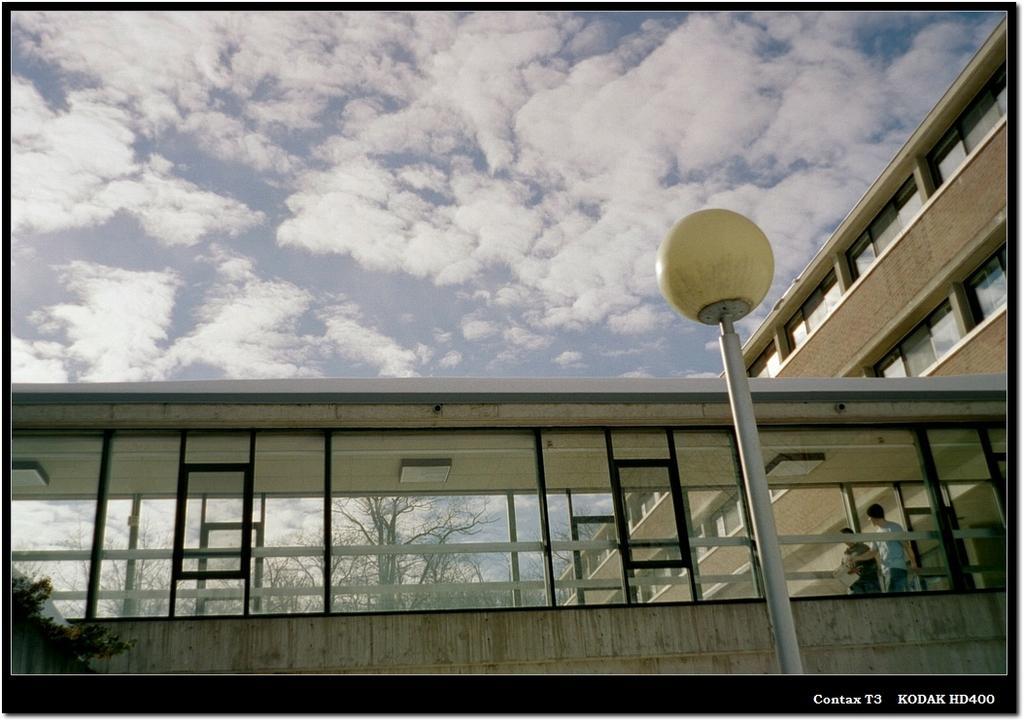Describe this image in one or two sentences. In this image there is a bridge in the middle. On the right side there is a pole on which there is a bulb. At the top there is the sky. On the right side there is a building with the glass windows. The bridge is covered with the glass and iron rods. 